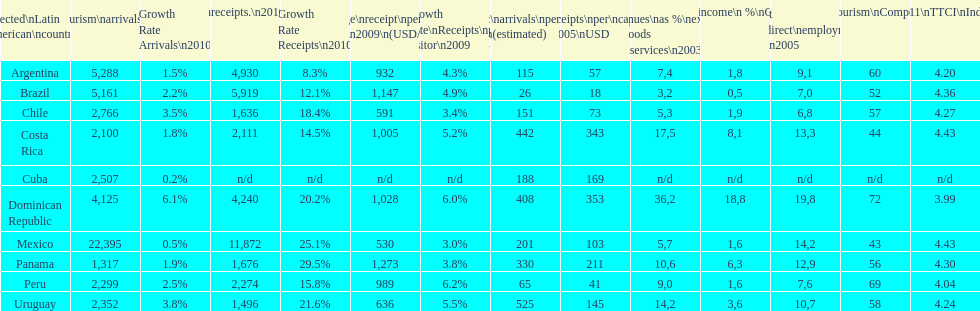What country makes the most tourist income? Dominican Republic. 